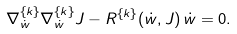<formula> <loc_0><loc_0><loc_500><loc_500>\nabla ^ { \{ k \} } _ { \dot { w } } \nabla ^ { \{ k \} } _ { \dot { w } } J - R ^ { \{ k \} } ( \dot { w } , J ) \, \dot { w } = 0 .</formula> 